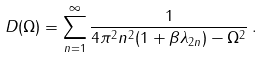<formula> <loc_0><loc_0><loc_500><loc_500>D ( \Omega ) = \sum _ { n = 1 } ^ { \infty } \frac { 1 } { 4 \pi ^ { 2 } n ^ { 2 } ( 1 + \beta \lambda _ { 2 n } ) - \Omega ^ { 2 } } \, .</formula> 